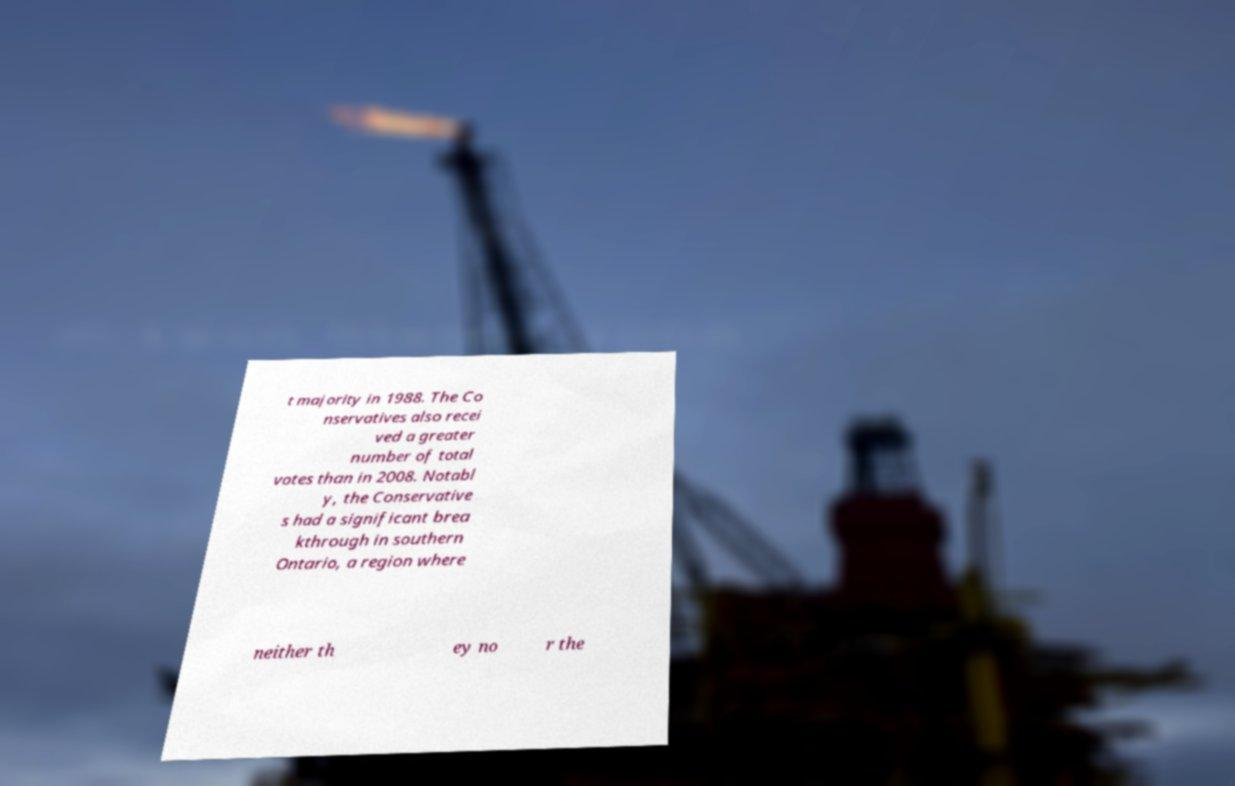I need the written content from this picture converted into text. Can you do that? t majority in 1988. The Co nservatives also recei ved a greater number of total votes than in 2008. Notabl y, the Conservative s had a significant brea kthrough in southern Ontario, a region where neither th ey no r the 